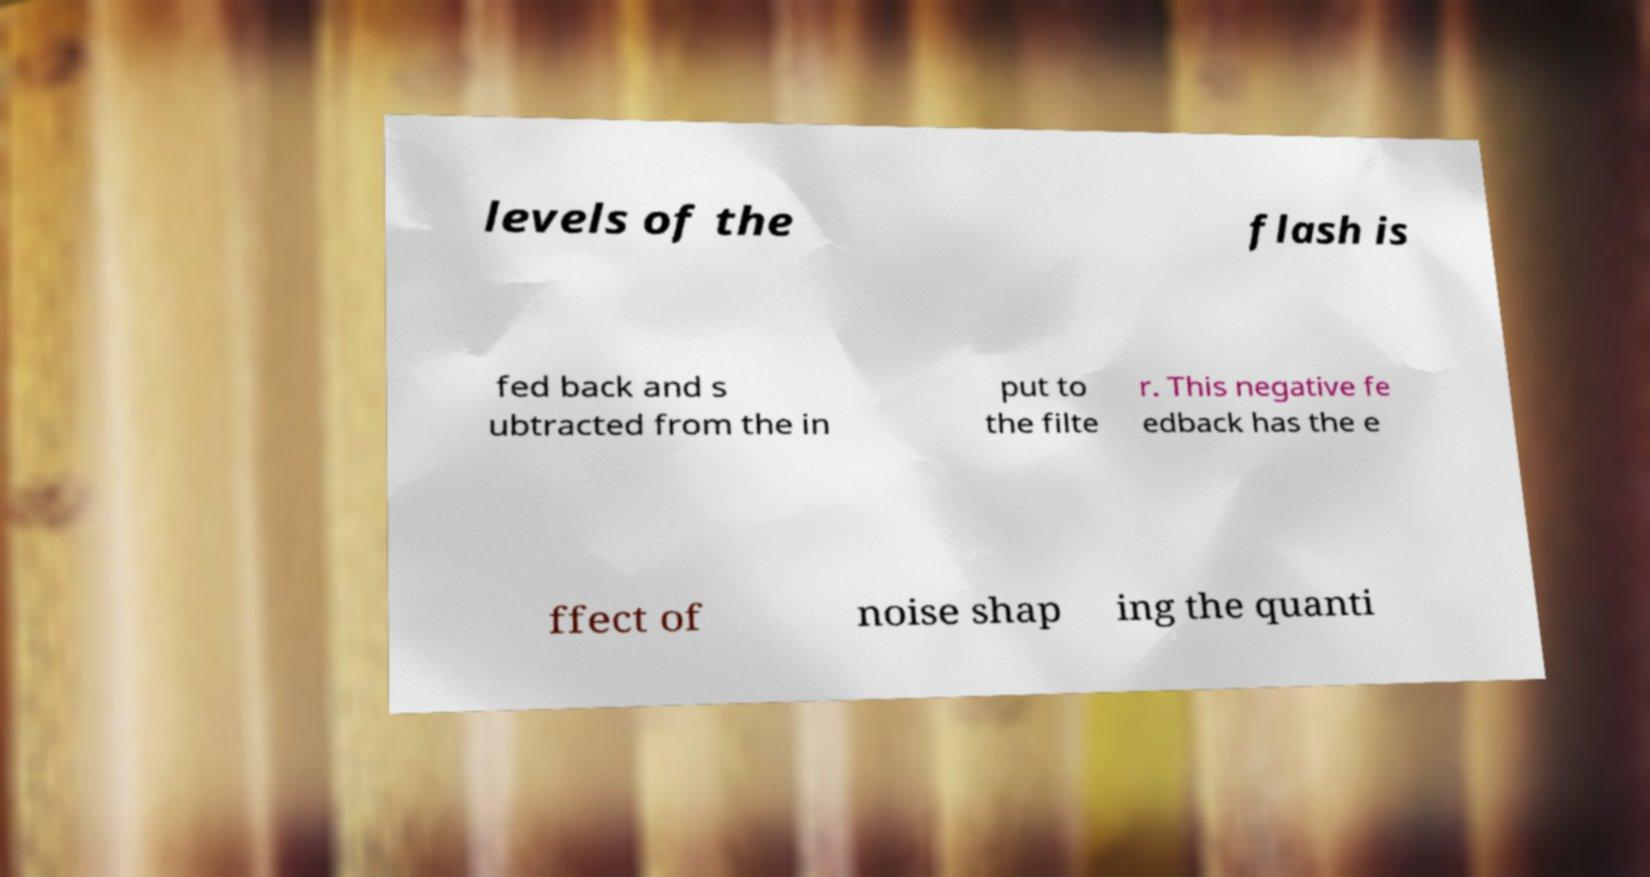Please identify and transcribe the text found in this image. levels of the flash is fed back and s ubtracted from the in put to the filte r. This negative fe edback has the e ffect of noise shap ing the quanti 